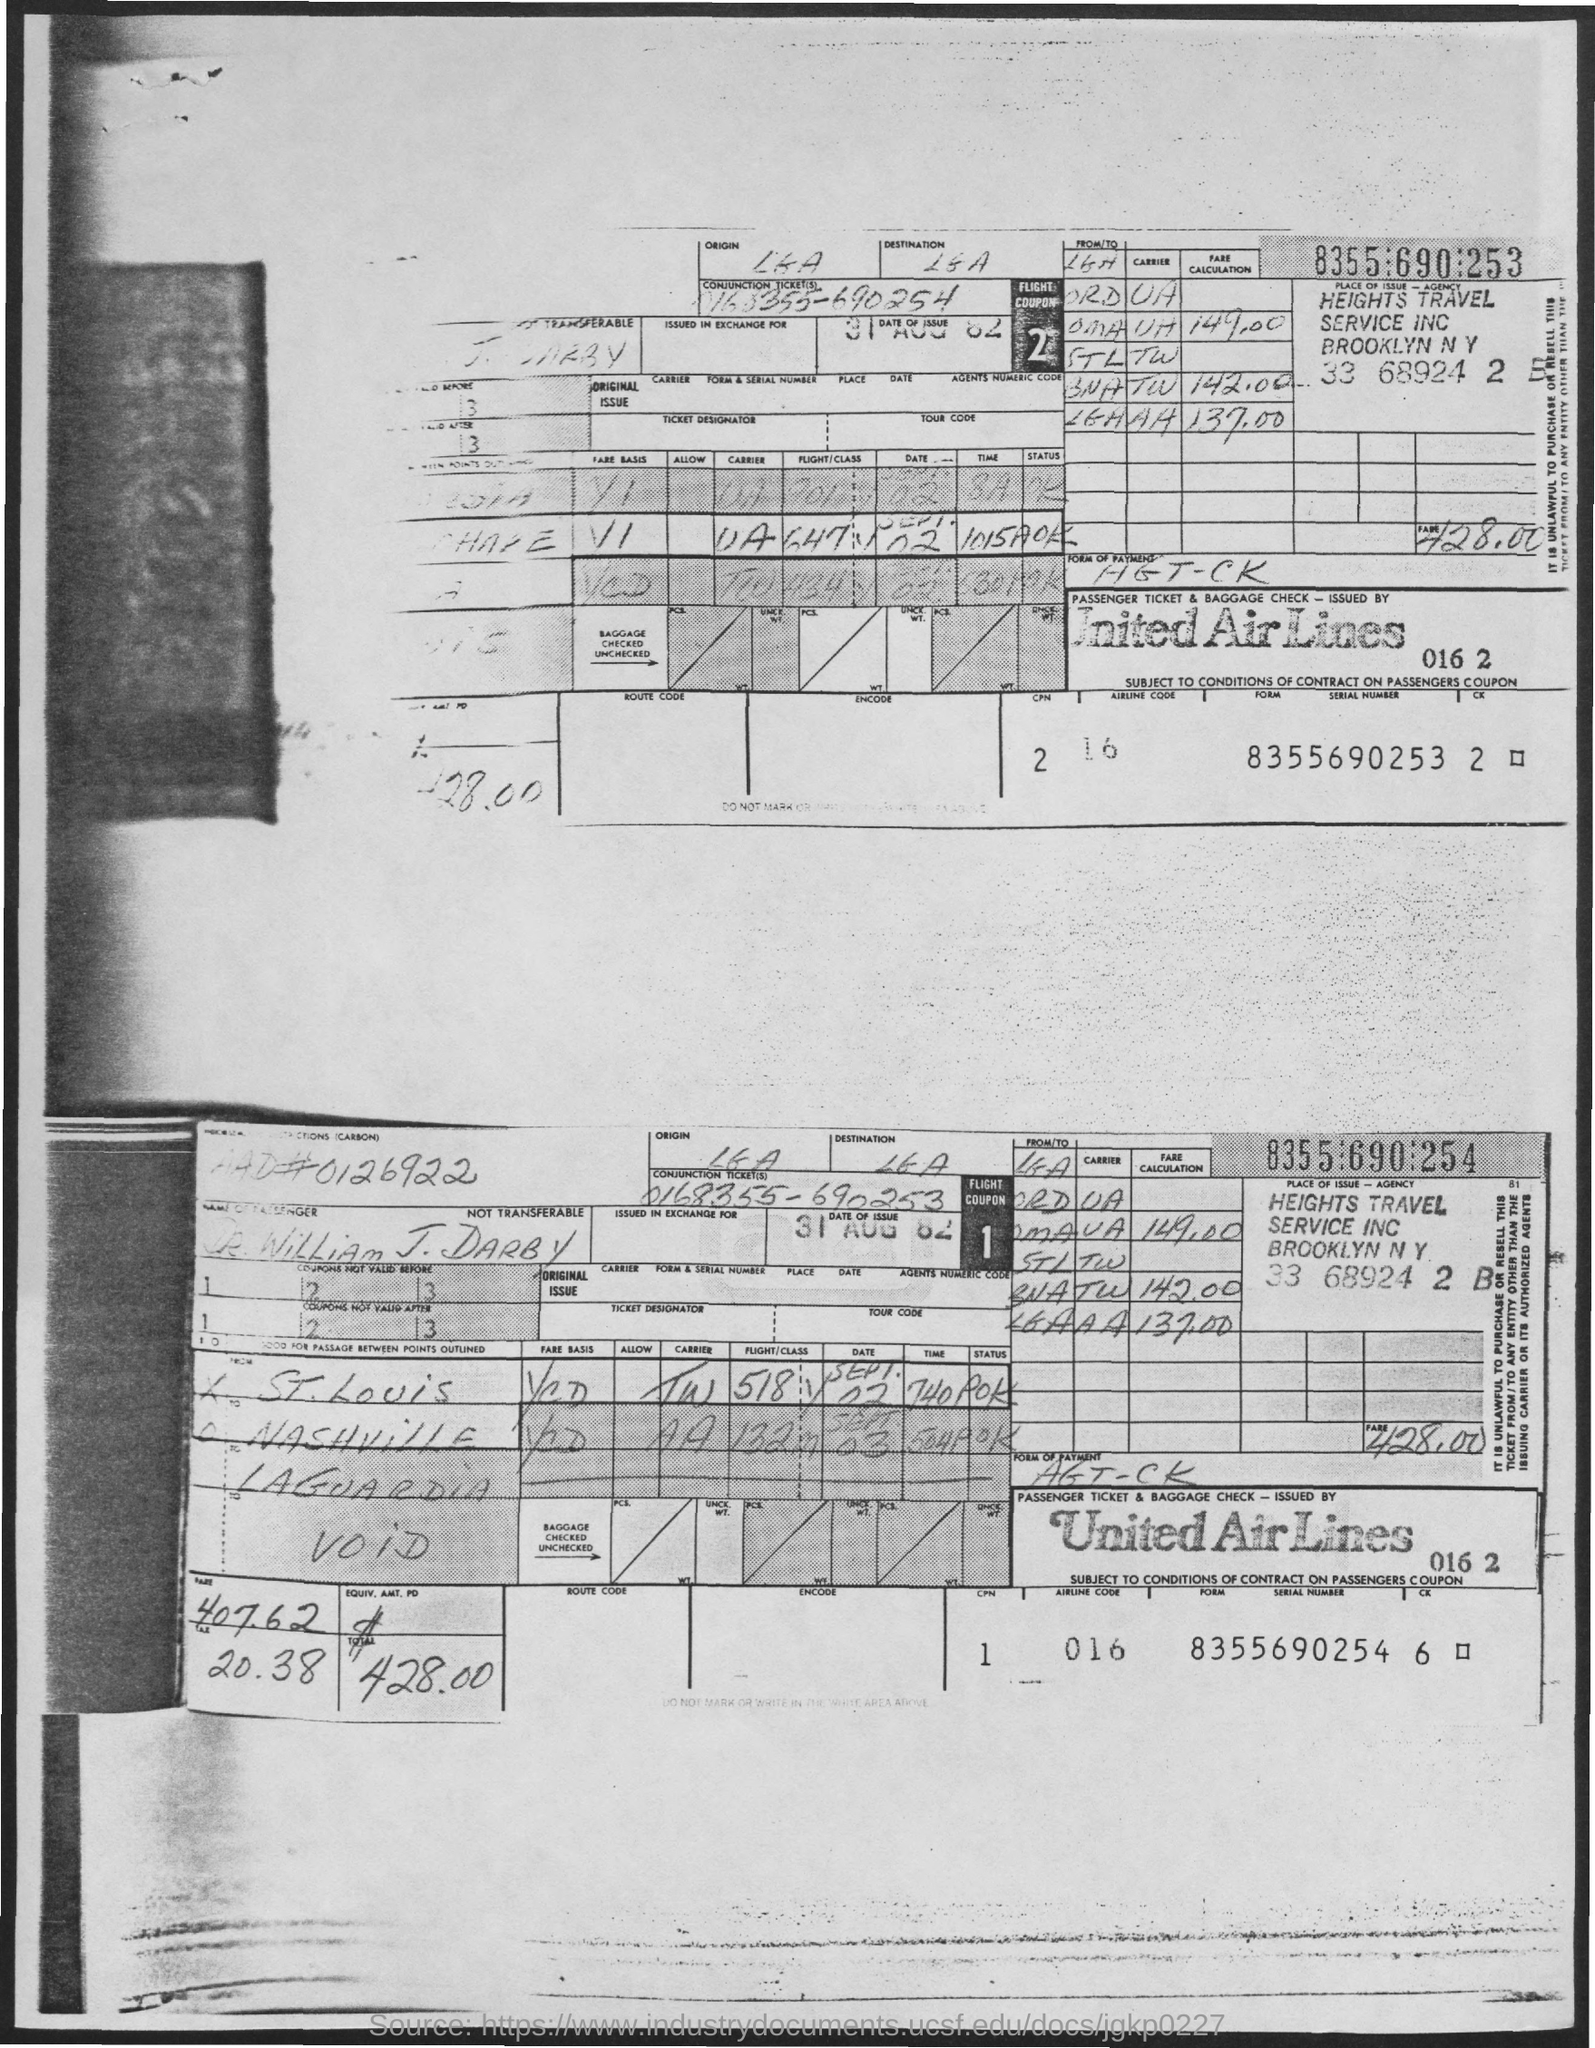Highlight a few significant elements in this photo. The ticket number of Flight Coupon 1 is 0168355-690253. United Airlines is the name of a well-known airline. The serial number of Flight Coupon 1 is 8355690254. The serial number of Flight Coupon 2 is 8355690253. It is important to note that the date of the issuance of both coupons is August 31, 1982. 